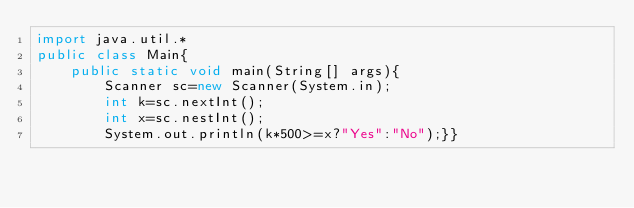Convert code to text. <code><loc_0><loc_0><loc_500><loc_500><_Java_>import java.util.*
public class Main{
	public static void main(String[] args){
    	Scanner sc=new Scanner(System.in);
    	int k=sc.nextInt();
        int x=sc.nestInt();
        System.out.println(k*500>=x?"Yes":"No");}}</code> 